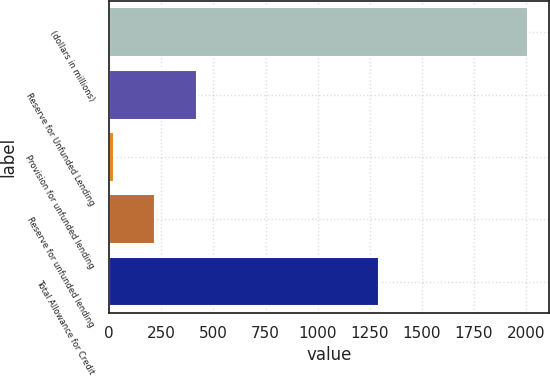Convert chart to OTSL. <chart><loc_0><loc_0><loc_500><loc_500><bar_chart><fcel>(dollars in millions)<fcel>Reserve for Unfunded Lending<fcel>Provision for unfunded lending<fcel>Reserve for unfunded lending<fcel>Total Allowance for Credit<nl><fcel>2012<fcel>419.2<fcel>21<fcel>220.1<fcel>1295<nl></chart> 